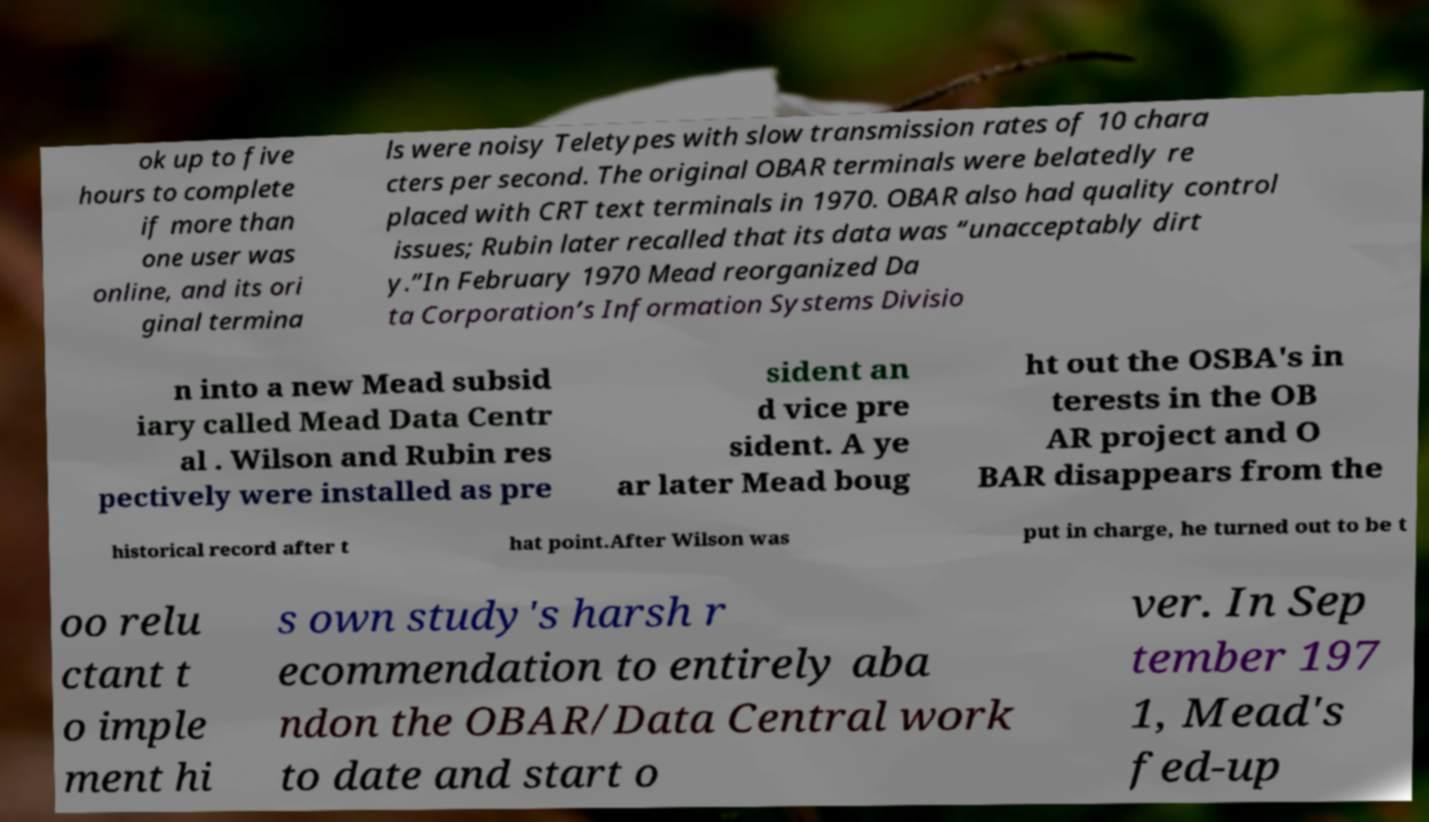What messages or text are displayed in this image? I need them in a readable, typed format. ok up to five hours to complete if more than one user was online, and its ori ginal termina ls were noisy Teletypes with slow transmission rates of 10 chara cters per second. The original OBAR terminals were belatedly re placed with CRT text terminals in 1970. OBAR also had quality control issues; Rubin later recalled that its data was “unacceptably dirt y.”In February 1970 Mead reorganized Da ta Corporation’s Information Systems Divisio n into a new Mead subsid iary called Mead Data Centr al . Wilson and Rubin res pectively were installed as pre sident an d vice pre sident. A ye ar later Mead boug ht out the OSBA's in terests in the OB AR project and O BAR disappears from the historical record after t hat point.After Wilson was put in charge, he turned out to be t oo relu ctant t o imple ment hi s own study's harsh r ecommendation to entirely aba ndon the OBAR/Data Central work to date and start o ver. In Sep tember 197 1, Mead's fed-up 